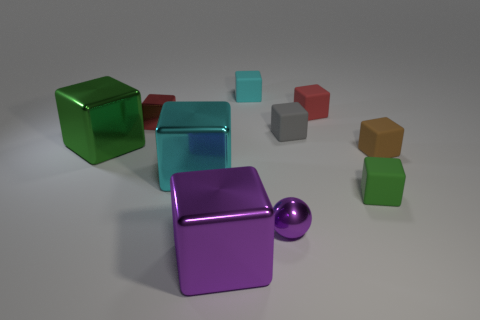Can you propose a narrative that might explain what's happening in this scene? One could imagine this scene as a snapshot from a futuristic setting, where these cubes and the sphere are part of a sophisticated puzzle or game. The arrangement might represent the starting point of a challenge, where the objects' positions hold meaning, awaiting interaction or movement as part of the gameplay. 